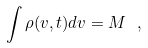Convert formula to latex. <formula><loc_0><loc_0><loc_500><loc_500>\int \rho ( v , t ) d v = M \ ,</formula> 